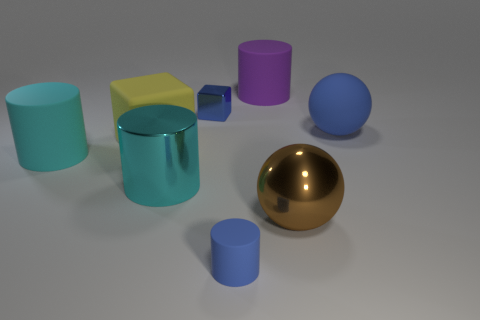Add 1 small blue blocks. How many objects exist? 9 Subtract all spheres. How many objects are left? 6 Add 5 small blue matte cylinders. How many small blue matte cylinders exist? 6 Subtract 0 green cylinders. How many objects are left? 8 Subtract all large rubber things. Subtract all gray rubber objects. How many objects are left? 4 Add 5 brown spheres. How many brown spheres are left? 6 